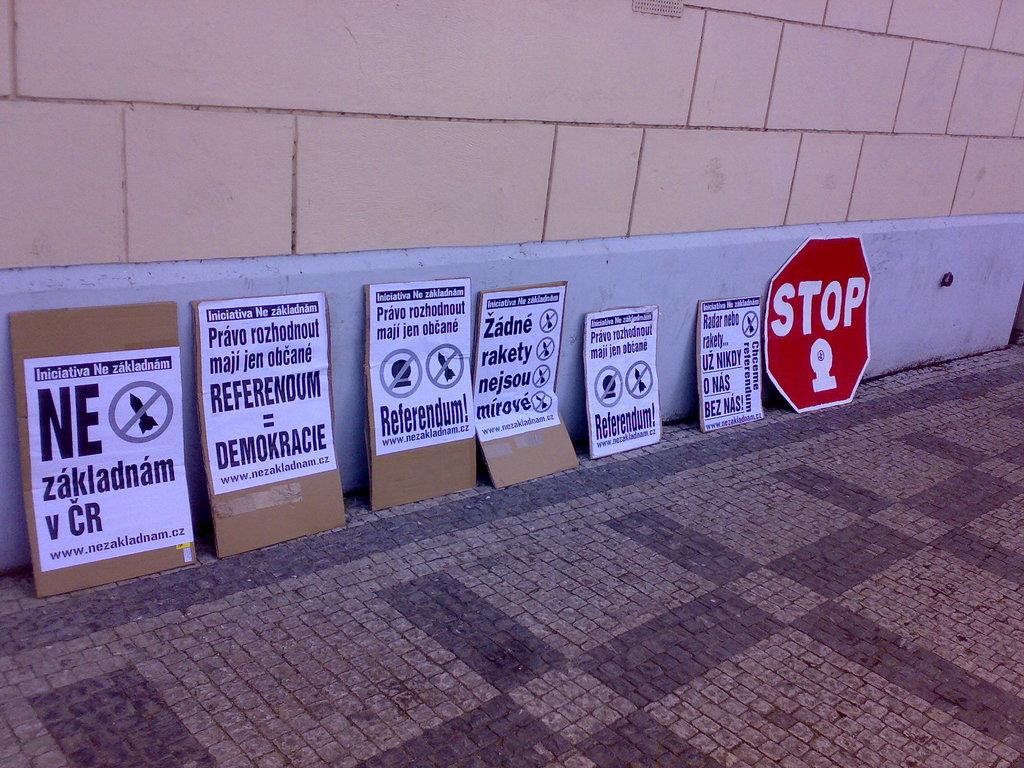What's the red sign say?
Make the answer very short. Stop. What are the two large letters on the left?
Offer a very short reply. Ne. 